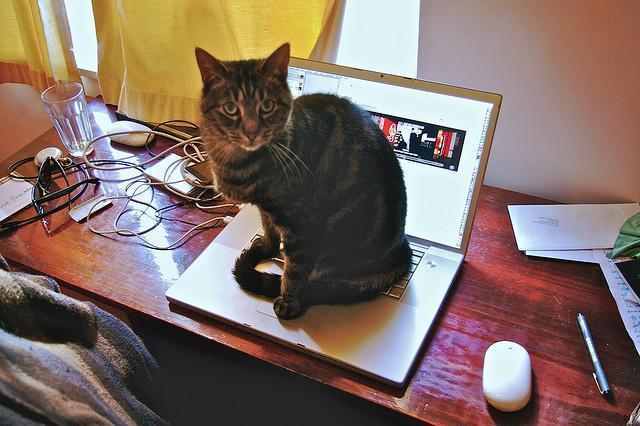How many mice are in the picture?
Give a very brief answer. 1. 